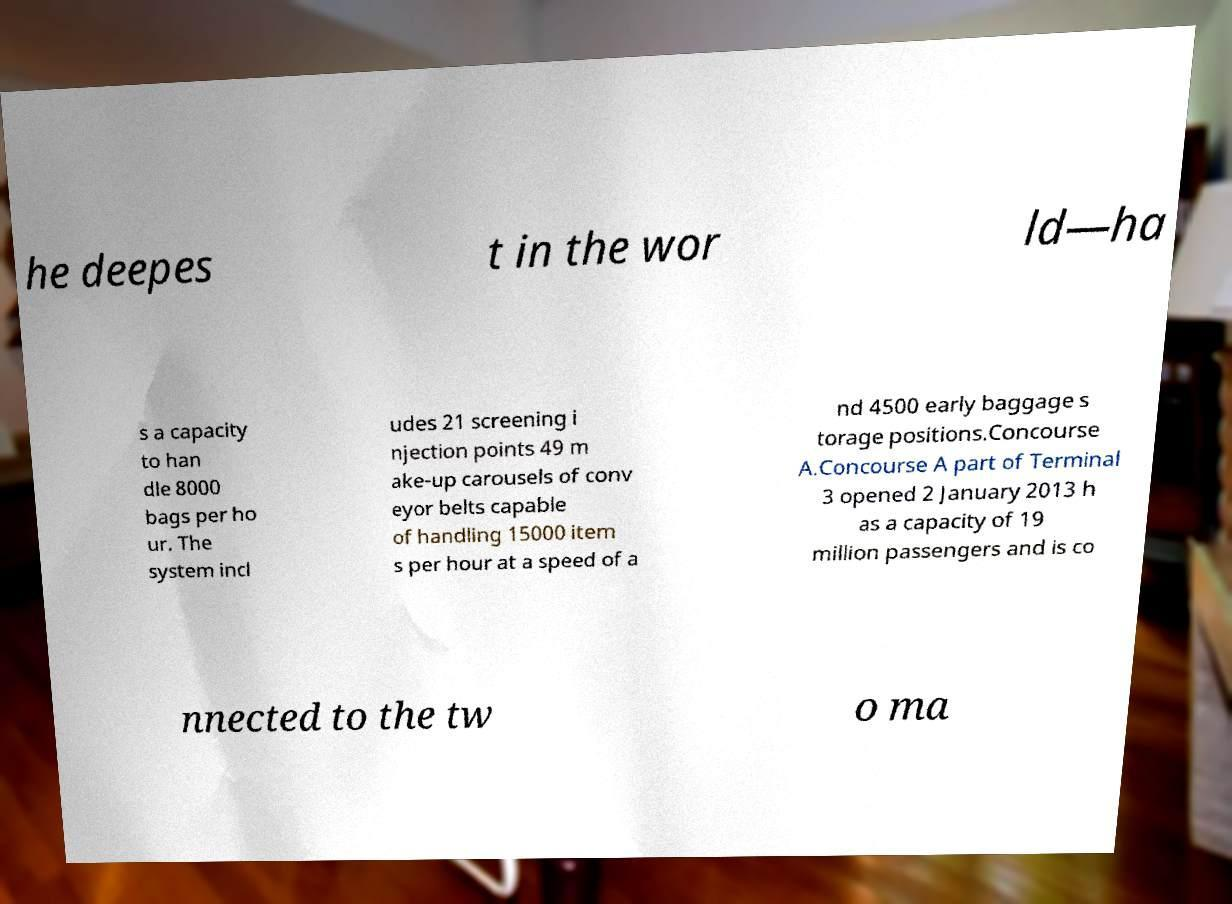Could you assist in decoding the text presented in this image and type it out clearly? he deepes t in the wor ld—ha s a capacity to han dle 8000 bags per ho ur. The system incl udes 21 screening i njection points 49 m ake-up carousels of conv eyor belts capable of handling 15000 item s per hour at a speed of a nd 4500 early baggage s torage positions.Concourse A.Concourse A part of Terminal 3 opened 2 January 2013 h as a capacity of 19 million passengers and is co nnected to the tw o ma 